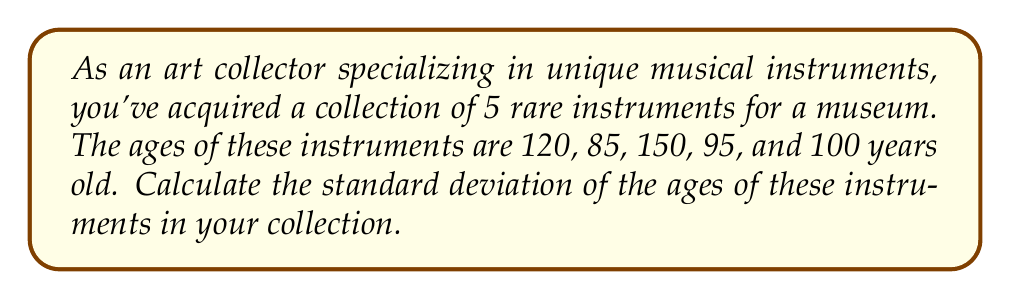Can you solve this math problem? To calculate the standard deviation, we'll follow these steps:

1. Calculate the mean age:
   $$\bar{x} = \frac{120 + 85 + 150 + 95 + 100}{5} = 110$$

2. Calculate the squared differences from the mean:
   $$(120 - 110)^2 = 100$$
   $$(85 - 110)^2 = 625$$
   $$(150 - 110)^2 = 1600$$
   $$(95 - 110)^2 = 225$$
   $$(100 - 110)^2 = 100$$

3. Calculate the average of the squared differences:
   $$\frac{100 + 625 + 1600 + 225 + 100}{5} = 530$$

4. Take the square root of the result:
   $$\sqrt{530} \approx 23.02$$

The formula for standard deviation is:

$$s = \sqrt{\frac{\sum_{i=1}^{n} (x_i - \bar{x})^2}{n}}$$

Where $s$ is the standard deviation, $x_i$ are the individual values, $\bar{x}$ is the mean, and $n$ is the number of values.
Answer: $23.02$ years 